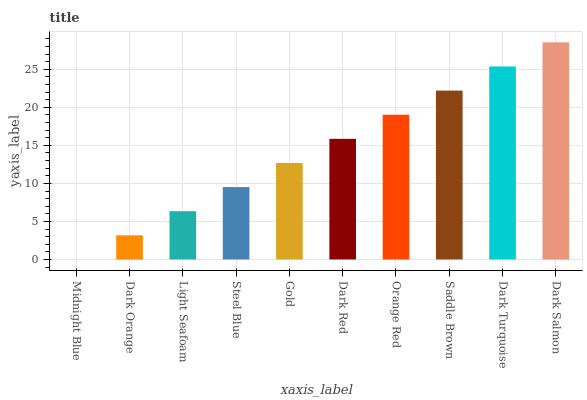Is Midnight Blue the minimum?
Answer yes or no. Yes. Is Dark Salmon the maximum?
Answer yes or no. Yes. Is Dark Orange the minimum?
Answer yes or no. No. Is Dark Orange the maximum?
Answer yes or no. No. Is Dark Orange greater than Midnight Blue?
Answer yes or no. Yes. Is Midnight Blue less than Dark Orange?
Answer yes or no. Yes. Is Midnight Blue greater than Dark Orange?
Answer yes or no. No. Is Dark Orange less than Midnight Blue?
Answer yes or no. No. Is Dark Red the high median?
Answer yes or no. Yes. Is Gold the low median?
Answer yes or no. Yes. Is Orange Red the high median?
Answer yes or no. No. Is Dark Turquoise the low median?
Answer yes or no. No. 